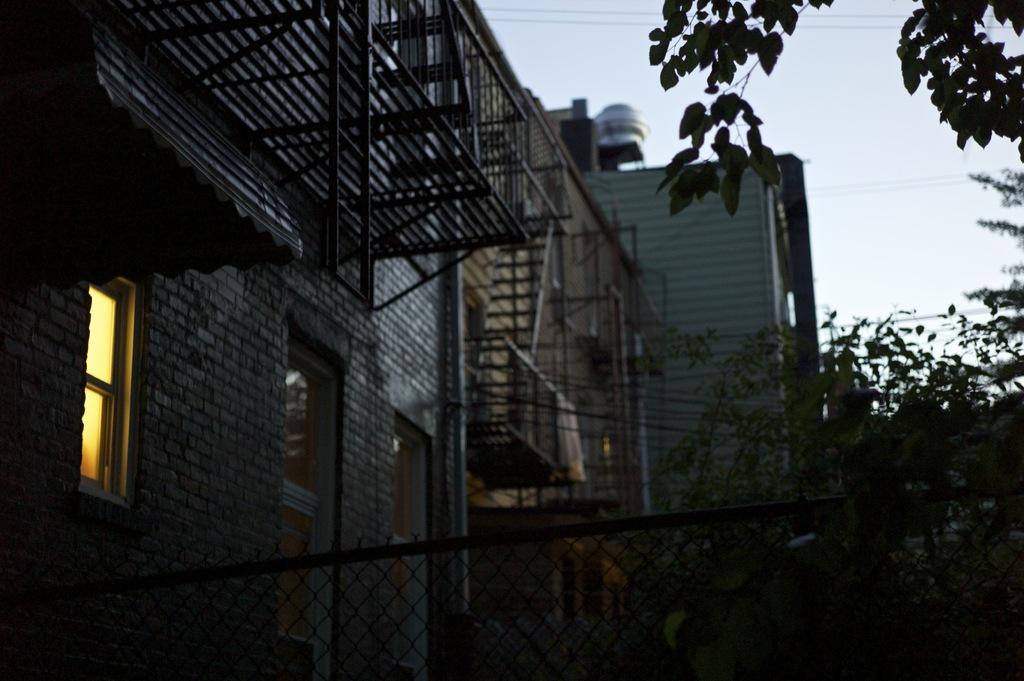Could you give a brief overview of what you see in this image? In this picture we can see mesh, buildings, leaves, windows, wires and railings. In the background of the image we can see the sky. 